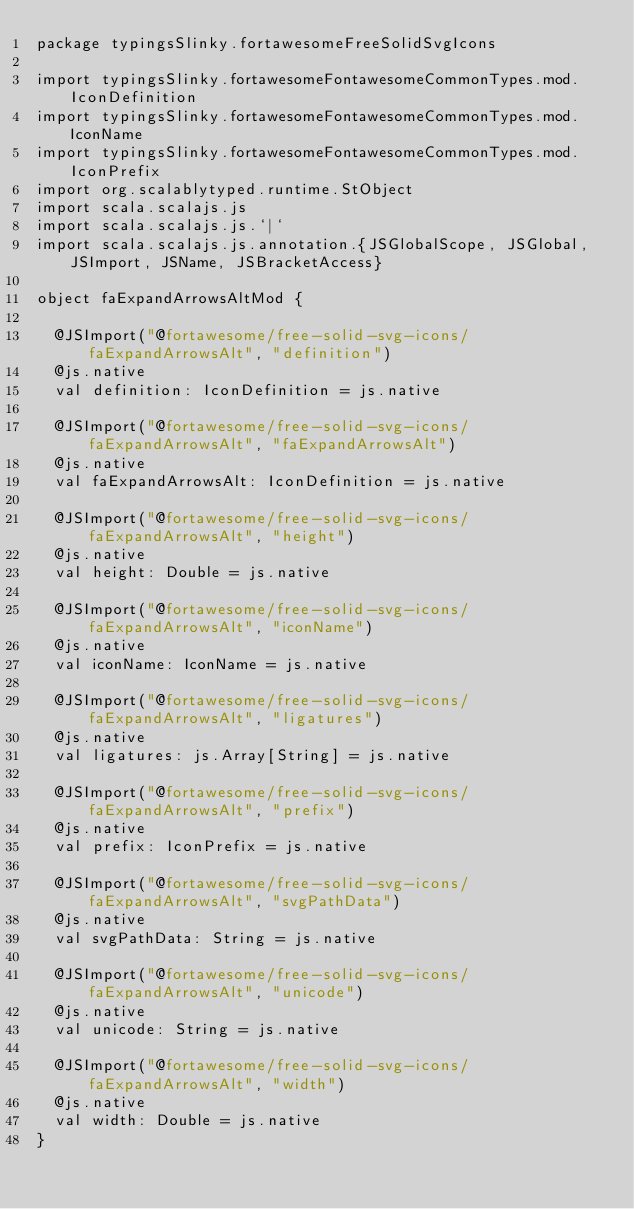Convert code to text. <code><loc_0><loc_0><loc_500><loc_500><_Scala_>package typingsSlinky.fortawesomeFreeSolidSvgIcons

import typingsSlinky.fortawesomeFontawesomeCommonTypes.mod.IconDefinition
import typingsSlinky.fortawesomeFontawesomeCommonTypes.mod.IconName
import typingsSlinky.fortawesomeFontawesomeCommonTypes.mod.IconPrefix
import org.scalablytyped.runtime.StObject
import scala.scalajs.js
import scala.scalajs.js.`|`
import scala.scalajs.js.annotation.{JSGlobalScope, JSGlobal, JSImport, JSName, JSBracketAccess}

object faExpandArrowsAltMod {
  
  @JSImport("@fortawesome/free-solid-svg-icons/faExpandArrowsAlt", "definition")
  @js.native
  val definition: IconDefinition = js.native
  
  @JSImport("@fortawesome/free-solid-svg-icons/faExpandArrowsAlt", "faExpandArrowsAlt")
  @js.native
  val faExpandArrowsAlt: IconDefinition = js.native
  
  @JSImport("@fortawesome/free-solid-svg-icons/faExpandArrowsAlt", "height")
  @js.native
  val height: Double = js.native
  
  @JSImport("@fortawesome/free-solid-svg-icons/faExpandArrowsAlt", "iconName")
  @js.native
  val iconName: IconName = js.native
  
  @JSImport("@fortawesome/free-solid-svg-icons/faExpandArrowsAlt", "ligatures")
  @js.native
  val ligatures: js.Array[String] = js.native
  
  @JSImport("@fortawesome/free-solid-svg-icons/faExpandArrowsAlt", "prefix")
  @js.native
  val prefix: IconPrefix = js.native
  
  @JSImport("@fortawesome/free-solid-svg-icons/faExpandArrowsAlt", "svgPathData")
  @js.native
  val svgPathData: String = js.native
  
  @JSImport("@fortawesome/free-solid-svg-icons/faExpandArrowsAlt", "unicode")
  @js.native
  val unicode: String = js.native
  
  @JSImport("@fortawesome/free-solid-svg-icons/faExpandArrowsAlt", "width")
  @js.native
  val width: Double = js.native
}
</code> 